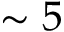<formula> <loc_0><loc_0><loc_500><loc_500>\sim 5</formula> 